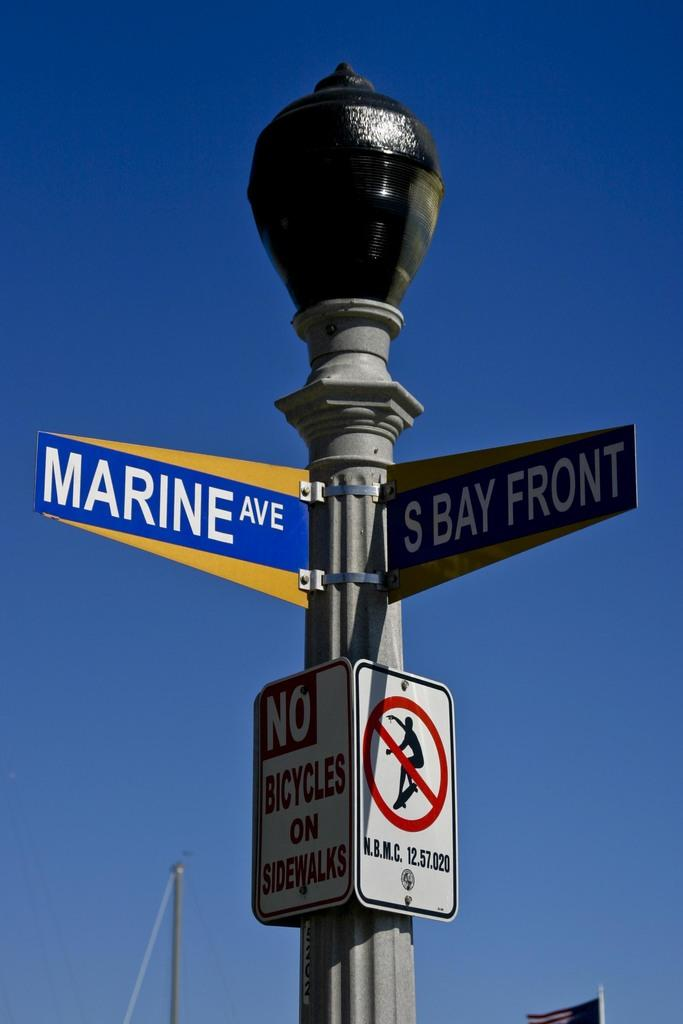<image>
Provide a brief description of the given image. A street sign at the corner of Marine Ave and S Bay Front 